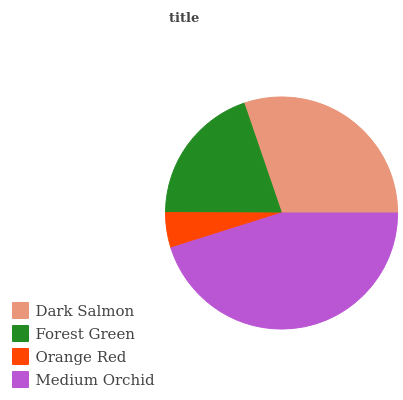Is Orange Red the minimum?
Answer yes or no. Yes. Is Medium Orchid the maximum?
Answer yes or no. Yes. Is Forest Green the minimum?
Answer yes or no. No. Is Forest Green the maximum?
Answer yes or no. No. Is Dark Salmon greater than Forest Green?
Answer yes or no. Yes. Is Forest Green less than Dark Salmon?
Answer yes or no. Yes. Is Forest Green greater than Dark Salmon?
Answer yes or no. No. Is Dark Salmon less than Forest Green?
Answer yes or no. No. Is Dark Salmon the high median?
Answer yes or no. Yes. Is Forest Green the low median?
Answer yes or no. Yes. Is Medium Orchid the high median?
Answer yes or no. No. Is Dark Salmon the low median?
Answer yes or no. No. 